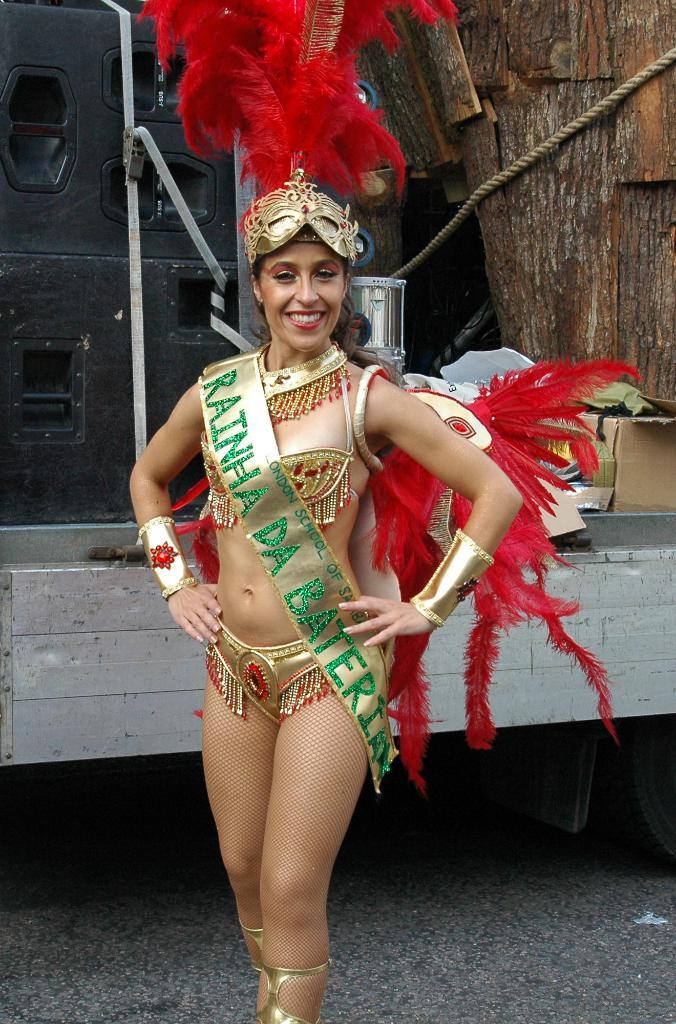Who is the main subject in the image? There is a woman in the image. Where is the woman positioned in the image? The woman is standing in the center of the image. What is the woman doing in the image? The woman is posing for the picture. What is the woman wearing in the image? The woman is wearing a banner with some text. What can be seen behind the woman in the image? There is a wooden construction behind her. How much payment is required to use the net in the image? There is no net present in the image, and therefore no payment is required for its use. 